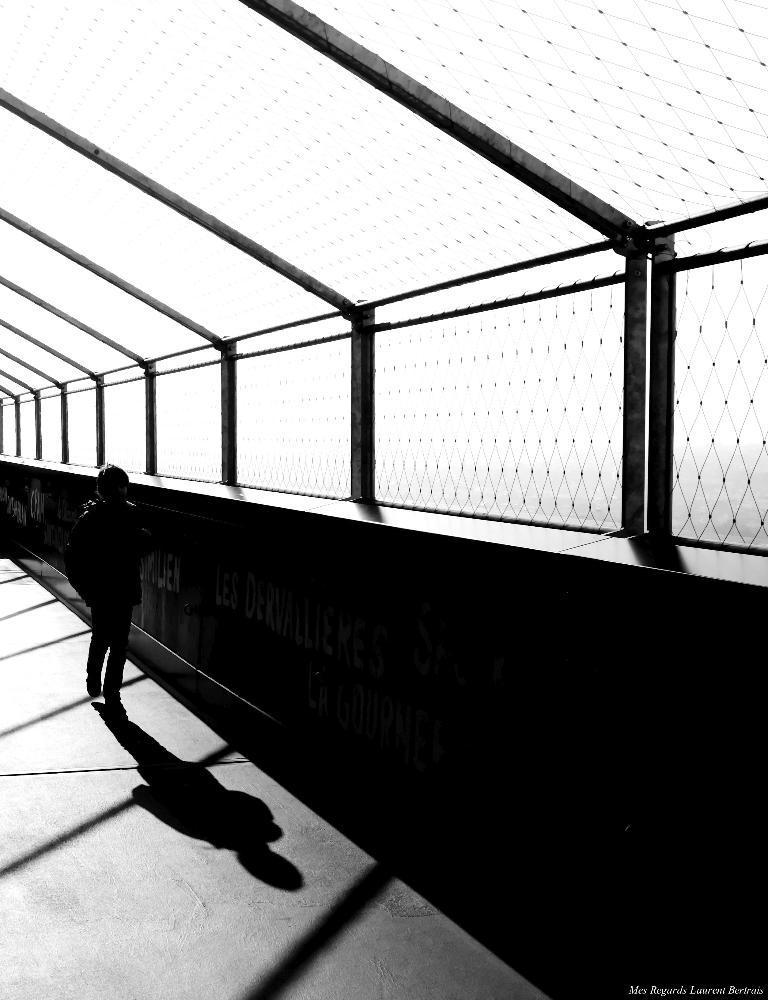Could you give a brief overview of what you see in this image? This is a black and white image. This picture is an inside view of a building. On the left side of the image we can see a person is walking on the floor. In the background of the image we can see the wall, mesh. In the bottom right corner we can see the text. 